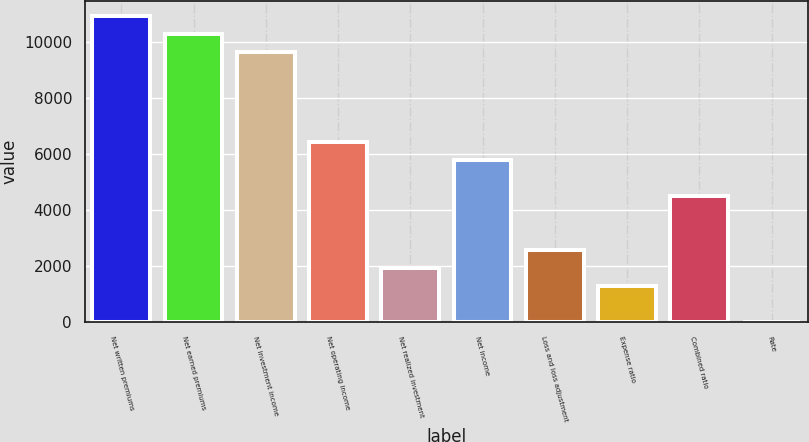<chart> <loc_0><loc_0><loc_500><loc_500><bar_chart><fcel>Net written premiums<fcel>Net earned premiums<fcel>Net investment income<fcel>Net operating income<fcel>Net realized investment<fcel>Net income<fcel>Loss and loss adjustment<fcel>Expense ratio<fcel>Combined ratio<fcel>Rate<nl><fcel>10915<fcel>10273<fcel>9631<fcel>6421<fcel>1927<fcel>5779<fcel>2569<fcel>1285<fcel>4495<fcel>1<nl></chart> 